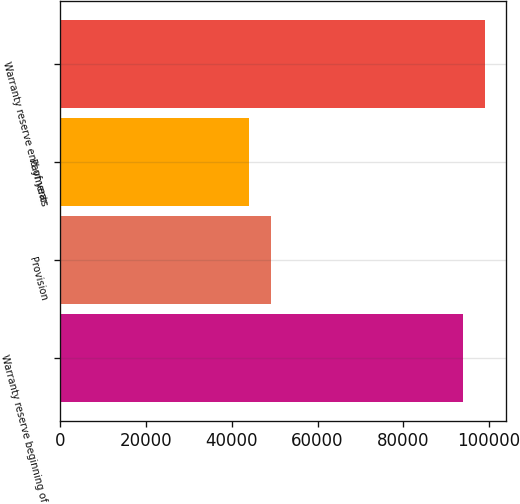Convert chart to OTSL. <chart><loc_0><loc_0><loc_500><loc_500><bar_chart><fcel>Warranty reserve beginning of<fcel>Provision<fcel>Payments<fcel>Warranty reserve end of year<nl><fcel>93895<fcel>49081.9<fcel>44034<fcel>98942.9<nl></chart> 